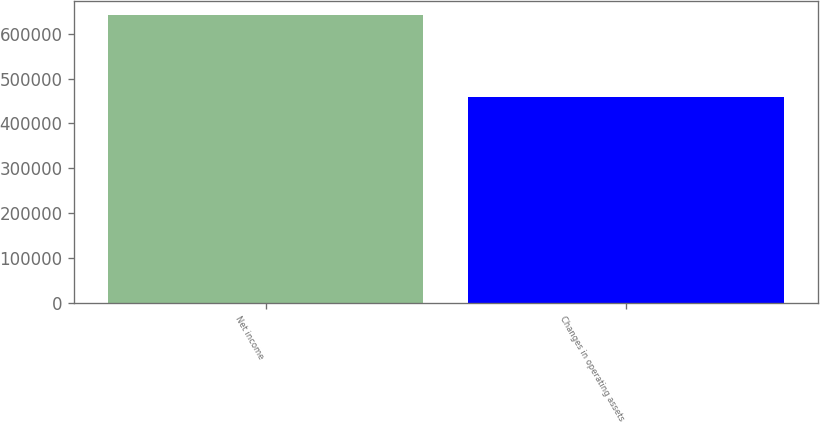<chart> <loc_0><loc_0><loc_500><loc_500><bar_chart><fcel>Net income<fcel>Changes in operating assets<nl><fcel>641237<fcel>459611<nl></chart> 